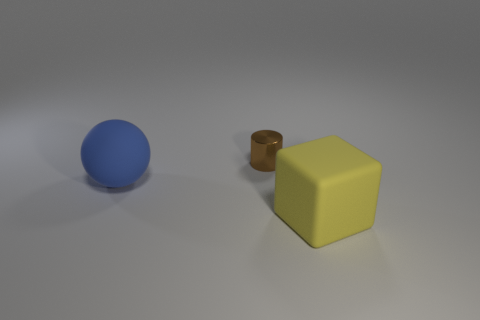Is there a large matte sphere on the right side of the matte object behind the large rubber thing on the right side of the large blue sphere?
Make the answer very short. No. How many big objects are brown metal cylinders or purple blocks?
Give a very brief answer. 0. There is a rubber object that is the same size as the rubber ball; what is its color?
Keep it short and to the point. Yellow. What number of balls are on the left side of the small brown metal thing?
Offer a terse response. 1. Is there a block made of the same material as the large sphere?
Offer a very short reply. Yes. There is a big matte thing that is on the left side of the brown cylinder; what color is it?
Your response must be concise. Blue. Is the number of small brown cylinders that are behind the cylinder the same as the number of tiny brown metal objects that are behind the large yellow rubber object?
Make the answer very short. No. What material is the big thing behind the yellow thing that is on the right side of the brown object?
Your response must be concise. Rubber. What number of objects are large blue matte objects or big rubber things to the left of the large block?
Give a very brief answer. 1. There is a yellow cube that is the same material as the blue sphere; what size is it?
Your answer should be very brief. Large. 